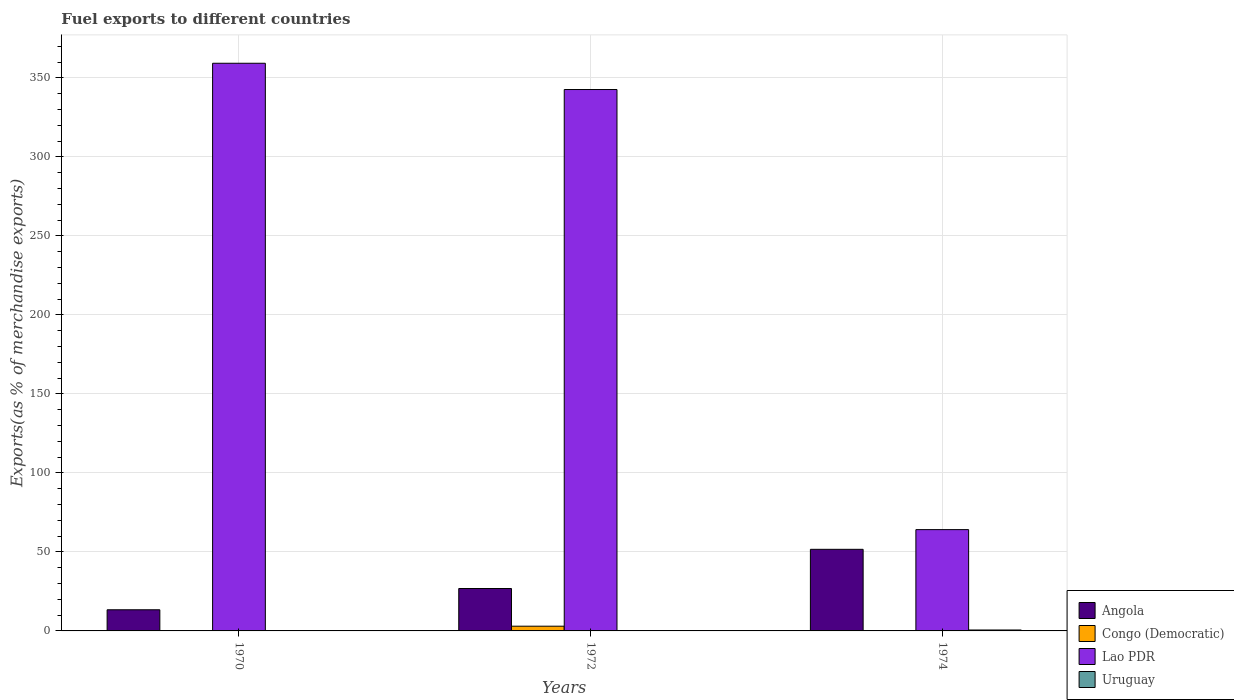How many different coloured bars are there?
Your response must be concise. 4. Are the number of bars per tick equal to the number of legend labels?
Your answer should be very brief. Yes. Are the number of bars on each tick of the X-axis equal?
Give a very brief answer. Yes. How many bars are there on the 3rd tick from the right?
Ensure brevity in your answer.  4. What is the label of the 3rd group of bars from the left?
Give a very brief answer. 1974. In how many cases, is the number of bars for a given year not equal to the number of legend labels?
Offer a terse response. 0. What is the percentage of exports to different countries in Angola in 1972?
Your response must be concise. 26.84. Across all years, what is the maximum percentage of exports to different countries in Congo (Democratic)?
Your answer should be compact. 2.99. Across all years, what is the minimum percentage of exports to different countries in Congo (Democratic)?
Make the answer very short. 0.16. In which year was the percentage of exports to different countries in Uruguay minimum?
Your answer should be very brief. 1970. What is the total percentage of exports to different countries in Congo (Democratic) in the graph?
Your answer should be compact. 3.32. What is the difference between the percentage of exports to different countries in Angola in 1972 and that in 1974?
Provide a short and direct response. -24.8. What is the difference between the percentage of exports to different countries in Angola in 1974 and the percentage of exports to different countries in Lao PDR in 1972?
Offer a very short reply. -291. What is the average percentage of exports to different countries in Uruguay per year?
Provide a succinct answer. 0.2. In the year 1974, what is the difference between the percentage of exports to different countries in Lao PDR and percentage of exports to different countries in Congo (Democratic)?
Your answer should be very brief. 63.95. In how many years, is the percentage of exports to different countries in Congo (Democratic) greater than 330 %?
Provide a short and direct response. 0. What is the ratio of the percentage of exports to different countries in Congo (Democratic) in 1970 to that in 1974?
Your answer should be compact. 1.12. Is the percentage of exports to different countries in Congo (Democratic) in 1970 less than that in 1974?
Offer a very short reply. No. Is the difference between the percentage of exports to different countries in Lao PDR in 1970 and 1974 greater than the difference between the percentage of exports to different countries in Congo (Democratic) in 1970 and 1974?
Your answer should be compact. Yes. What is the difference between the highest and the second highest percentage of exports to different countries in Angola?
Offer a terse response. 24.8. What is the difference between the highest and the lowest percentage of exports to different countries in Uruguay?
Provide a succinct answer. 0.58. What does the 3rd bar from the left in 1970 represents?
Offer a terse response. Lao PDR. What does the 3rd bar from the right in 1970 represents?
Provide a short and direct response. Congo (Democratic). How many bars are there?
Your answer should be very brief. 12. How many years are there in the graph?
Provide a short and direct response. 3. Are the values on the major ticks of Y-axis written in scientific E-notation?
Provide a succinct answer. No. Does the graph contain any zero values?
Offer a very short reply. No. Where does the legend appear in the graph?
Give a very brief answer. Bottom right. How are the legend labels stacked?
Give a very brief answer. Vertical. What is the title of the graph?
Give a very brief answer. Fuel exports to different countries. What is the label or title of the Y-axis?
Ensure brevity in your answer.  Exports(as % of merchandise exports). What is the Exports(as % of merchandise exports) of Angola in 1970?
Provide a succinct answer. 13.38. What is the Exports(as % of merchandise exports) in Congo (Democratic) in 1970?
Keep it short and to the point. 0.17. What is the Exports(as % of merchandise exports) of Lao PDR in 1970?
Your response must be concise. 359.26. What is the Exports(as % of merchandise exports) in Uruguay in 1970?
Make the answer very short. 0. What is the Exports(as % of merchandise exports) of Angola in 1972?
Your response must be concise. 26.84. What is the Exports(as % of merchandise exports) of Congo (Democratic) in 1972?
Your answer should be compact. 2.99. What is the Exports(as % of merchandise exports) in Lao PDR in 1972?
Offer a terse response. 342.64. What is the Exports(as % of merchandise exports) of Uruguay in 1972?
Keep it short and to the point. 0.03. What is the Exports(as % of merchandise exports) in Angola in 1974?
Offer a very short reply. 51.64. What is the Exports(as % of merchandise exports) of Congo (Democratic) in 1974?
Your answer should be compact. 0.16. What is the Exports(as % of merchandise exports) of Lao PDR in 1974?
Give a very brief answer. 64.11. What is the Exports(as % of merchandise exports) of Uruguay in 1974?
Offer a very short reply. 0.58. Across all years, what is the maximum Exports(as % of merchandise exports) in Angola?
Keep it short and to the point. 51.64. Across all years, what is the maximum Exports(as % of merchandise exports) in Congo (Democratic)?
Your answer should be very brief. 2.99. Across all years, what is the maximum Exports(as % of merchandise exports) of Lao PDR?
Keep it short and to the point. 359.26. Across all years, what is the maximum Exports(as % of merchandise exports) of Uruguay?
Provide a succinct answer. 0.58. Across all years, what is the minimum Exports(as % of merchandise exports) in Angola?
Your answer should be compact. 13.38. Across all years, what is the minimum Exports(as % of merchandise exports) in Congo (Democratic)?
Your response must be concise. 0.16. Across all years, what is the minimum Exports(as % of merchandise exports) in Lao PDR?
Make the answer very short. 64.11. Across all years, what is the minimum Exports(as % of merchandise exports) in Uruguay?
Your answer should be very brief. 0. What is the total Exports(as % of merchandise exports) of Angola in the graph?
Make the answer very short. 91.87. What is the total Exports(as % of merchandise exports) in Congo (Democratic) in the graph?
Your response must be concise. 3.32. What is the total Exports(as % of merchandise exports) of Lao PDR in the graph?
Ensure brevity in your answer.  766. What is the total Exports(as % of merchandise exports) of Uruguay in the graph?
Your answer should be very brief. 0.61. What is the difference between the Exports(as % of merchandise exports) in Angola in 1970 and that in 1972?
Offer a very short reply. -13.46. What is the difference between the Exports(as % of merchandise exports) of Congo (Democratic) in 1970 and that in 1972?
Your response must be concise. -2.81. What is the difference between the Exports(as % of merchandise exports) in Lao PDR in 1970 and that in 1972?
Provide a short and direct response. 16.62. What is the difference between the Exports(as % of merchandise exports) of Uruguay in 1970 and that in 1972?
Provide a succinct answer. -0.03. What is the difference between the Exports(as % of merchandise exports) in Angola in 1970 and that in 1974?
Provide a short and direct response. -38.26. What is the difference between the Exports(as % of merchandise exports) in Congo (Democratic) in 1970 and that in 1974?
Your response must be concise. 0.02. What is the difference between the Exports(as % of merchandise exports) of Lao PDR in 1970 and that in 1974?
Give a very brief answer. 295.15. What is the difference between the Exports(as % of merchandise exports) in Uruguay in 1970 and that in 1974?
Ensure brevity in your answer.  -0.58. What is the difference between the Exports(as % of merchandise exports) in Angola in 1972 and that in 1974?
Your answer should be compact. -24.8. What is the difference between the Exports(as % of merchandise exports) of Congo (Democratic) in 1972 and that in 1974?
Your response must be concise. 2.83. What is the difference between the Exports(as % of merchandise exports) in Lao PDR in 1972 and that in 1974?
Ensure brevity in your answer.  278.53. What is the difference between the Exports(as % of merchandise exports) of Uruguay in 1972 and that in 1974?
Provide a short and direct response. -0.55. What is the difference between the Exports(as % of merchandise exports) of Angola in 1970 and the Exports(as % of merchandise exports) of Congo (Democratic) in 1972?
Offer a terse response. 10.4. What is the difference between the Exports(as % of merchandise exports) in Angola in 1970 and the Exports(as % of merchandise exports) in Lao PDR in 1972?
Make the answer very short. -329.25. What is the difference between the Exports(as % of merchandise exports) in Angola in 1970 and the Exports(as % of merchandise exports) in Uruguay in 1972?
Give a very brief answer. 13.36. What is the difference between the Exports(as % of merchandise exports) in Congo (Democratic) in 1970 and the Exports(as % of merchandise exports) in Lao PDR in 1972?
Your answer should be very brief. -342.46. What is the difference between the Exports(as % of merchandise exports) in Congo (Democratic) in 1970 and the Exports(as % of merchandise exports) in Uruguay in 1972?
Keep it short and to the point. 0.15. What is the difference between the Exports(as % of merchandise exports) in Lao PDR in 1970 and the Exports(as % of merchandise exports) in Uruguay in 1972?
Offer a terse response. 359.23. What is the difference between the Exports(as % of merchandise exports) in Angola in 1970 and the Exports(as % of merchandise exports) in Congo (Democratic) in 1974?
Your answer should be compact. 13.23. What is the difference between the Exports(as % of merchandise exports) of Angola in 1970 and the Exports(as % of merchandise exports) of Lao PDR in 1974?
Ensure brevity in your answer.  -50.72. What is the difference between the Exports(as % of merchandise exports) in Angola in 1970 and the Exports(as % of merchandise exports) in Uruguay in 1974?
Your response must be concise. 12.8. What is the difference between the Exports(as % of merchandise exports) of Congo (Democratic) in 1970 and the Exports(as % of merchandise exports) of Lao PDR in 1974?
Your response must be concise. -63.93. What is the difference between the Exports(as % of merchandise exports) in Congo (Democratic) in 1970 and the Exports(as % of merchandise exports) in Uruguay in 1974?
Offer a very short reply. -0.41. What is the difference between the Exports(as % of merchandise exports) of Lao PDR in 1970 and the Exports(as % of merchandise exports) of Uruguay in 1974?
Ensure brevity in your answer.  358.67. What is the difference between the Exports(as % of merchandise exports) of Angola in 1972 and the Exports(as % of merchandise exports) of Congo (Democratic) in 1974?
Provide a short and direct response. 26.68. What is the difference between the Exports(as % of merchandise exports) in Angola in 1972 and the Exports(as % of merchandise exports) in Lao PDR in 1974?
Ensure brevity in your answer.  -37.27. What is the difference between the Exports(as % of merchandise exports) of Angola in 1972 and the Exports(as % of merchandise exports) of Uruguay in 1974?
Ensure brevity in your answer.  26.26. What is the difference between the Exports(as % of merchandise exports) in Congo (Democratic) in 1972 and the Exports(as % of merchandise exports) in Lao PDR in 1974?
Your response must be concise. -61.12. What is the difference between the Exports(as % of merchandise exports) of Congo (Democratic) in 1972 and the Exports(as % of merchandise exports) of Uruguay in 1974?
Give a very brief answer. 2.41. What is the difference between the Exports(as % of merchandise exports) in Lao PDR in 1972 and the Exports(as % of merchandise exports) in Uruguay in 1974?
Give a very brief answer. 342.06. What is the average Exports(as % of merchandise exports) of Angola per year?
Your answer should be compact. 30.62. What is the average Exports(as % of merchandise exports) in Congo (Democratic) per year?
Ensure brevity in your answer.  1.11. What is the average Exports(as % of merchandise exports) in Lao PDR per year?
Your response must be concise. 255.33. What is the average Exports(as % of merchandise exports) of Uruguay per year?
Give a very brief answer. 0.2. In the year 1970, what is the difference between the Exports(as % of merchandise exports) of Angola and Exports(as % of merchandise exports) of Congo (Democratic)?
Make the answer very short. 13.21. In the year 1970, what is the difference between the Exports(as % of merchandise exports) of Angola and Exports(as % of merchandise exports) of Lao PDR?
Offer a very short reply. -345.87. In the year 1970, what is the difference between the Exports(as % of merchandise exports) in Angola and Exports(as % of merchandise exports) in Uruguay?
Your response must be concise. 13.38. In the year 1970, what is the difference between the Exports(as % of merchandise exports) in Congo (Democratic) and Exports(as % of merchandise exports) in Lao PDR?
Your answer should be compact. -359.08. In the year 1970, what is the difference between the Exports(as % of merchandise exports) in Congo (Democratic) and Exports(as % of merchandise exports) in Uruguay?
Your response must be concise. 0.17. In the year 1970, what is the difference between the Exports(as % of merchandise exports) of Lao PDR and Exports(as % of merchandise exports) of Uruguay?
Your response must be concise. 359.25. In the year 1972, what is the difference between the Exports(as % of merchandise exports) of Angola and Exports(as % of merchandise exports) of Congo (Democratic)?
Ensure brevity in your answer.  23.85. In the year 1972, what is the difference between the Exports(as % of merchandise exports) in Angola and Exports(as % of merchandise exports) in Lao PDR?
Give a very brief answer. -315.8. In the year 1972, what is the difference between the Exports(as % of merchandise exports) of Angola and Exports(as % of merchandise exports) of Uruguay?
Provide a succinct answer. 26.81. In the year 1972, what is the difference between the Exports(as % of merchandise exports) in Congo (Democratic) and Exports(as % of merchandise exports) in Lao PDR?
Provide a short and direct response. -339.65. In the year 1972, what is the difference between the Exports(as % of merchandise exports) of Congo (Democratic) and Exports(as % of merchandise exports) of Uruguay?
Your answer should be very brief. 2.96. In the year 1972, what is the difference between the Exports(as % of merchandise exports) in Lao PDR and Exports(as % of merchandise exports) in Uruguay?
Provide a succinct answer. 342.61. In the year 1974, what is the difference between the Exports(as % of merchandise exports) in Angola and Exports(as % of merchandise exports) in Congo (Democratic)?
Make the answer very short. 51.49. In the year 1974, what is the difference between the Exports(as % of merchandise exports) in Angola and Exports(as % of merchandise exports) in Lao PDR?
Ensure brevity in your answer.  -12.47. In the year 1974, what is the difference between the Exports(as % of merchandise exports) in Angola and Exports(as % of merchandise exports) in Uruguay?
Your response must be concise. 51.06. In the year 1974, what is the difference between the Exports(as % of merchandise exports) of Congo (Democratic) and Exports(as % of merchandise exports) of Lao PDR?
Offer a very short reply. -63.95. In the year 1974, what is the difference between the Exports(as % of merchandise exports) in Congo (Democratic) and Exports(as % of merchandise exports) in Uruguay?
Offer a very short reply. -0.43. In the year 1974, what is the difference between the Exports(as % of merchandise exports) in Lao PDR and Exports(as % of merchandise exports) in Uruguay?
Make the answer very short. 63.52. What is the ratio of the Exports(as % of merchandise exports) of Angola in 1970 to that in 1972?
Give a very brief answer. 0.5. What is the ratio of the Exports(as % of merchandise exports) of Congo (Democratic) in 1970 to that in 1972?
Provide a succinct answer. 0.06. What is the ratio of the Exports(as % of merchandise exports) in Lao PDR in 1970 to that in 1972?
Offer a very short reply. 1.05. What is the ratio of the Exports(as % of merchandise exports) in Uruguay in 1970 to that in 1972?
Provide a succinct answer. 0.07. What is the ratio of the Exports(as % of merchandise exports) of Angola in 1970 to that in 1974?
Give a very brief answer. 0.26. What is the ratio of the Exports(as % of merchandise exports) of Congo (Democratic) in 1970 to that in 1974?
Offer a very short reply. 1.12. What is the ratio of the Exports(as % of merchandise exports) in Lao PDR in 1970 to that in 1974?
Offer a very short reply. 5.6. What is the ratio of the Exports(as % of merchandise exports) of Uruguay in 1970 to that in 1974?
Provide a succinct answer. 0. What is the ratio of the Exports(as % of merchandise exports) of Angola in 1972 to that in 1974?
Your answer should be very brief. 0.52. What is the ratio of the Exports(as % of merchandise exports) in Congo (Democratic) in 1972 to that in 1974?
Your response must be concise. 19.11. What is the ratio of the Exports(as % of merchandise exports) of Lao PDR in 1972 to that in 1974?
Keep it short and to the point. 5.34. What is the ratio of the Exports(as % of merchandise exports) in Uruguay in 1972 to that in 1974?
Offer a terse response. 0.05. What is the difference between the highest and the second highest Exports(as % of merchandise exports) in Angola?
Provide a short and direct response. 24.8. What is the difference between the highest and the second highest Exports(as % of merchandise exports) of Congo (Democratic)?
Your response must be concise. 2.81. What is the difference between the highest and the second highest Exports(as % of merchandise exports) in Lao PDR?
Ensure brevity in your answer.  16.62. What is the difference between the highest and the second highest Exports(as % of merchandise exports) of Uruguay?
Offer a very short reply. 0.55. What is the difference between the highest and the lowest Exports(as % of merchandise exports) of Angola?
Make the answer very short. 38.26. What is the difference between the highest and the lowest Exports(as % of merchandise exports) of Congo (Democratic)?
Provide a succinct answer. 2.83. What is the difference between the highest and the lowest Exports(as % of merchandise exports) of Lao PDR?
Your answer should be very brief. 295.15. What is the difference between the highest and the lowest Exports(as % of merchandise exports) of Uruguay?
Give a very brief answer. 0.58. 